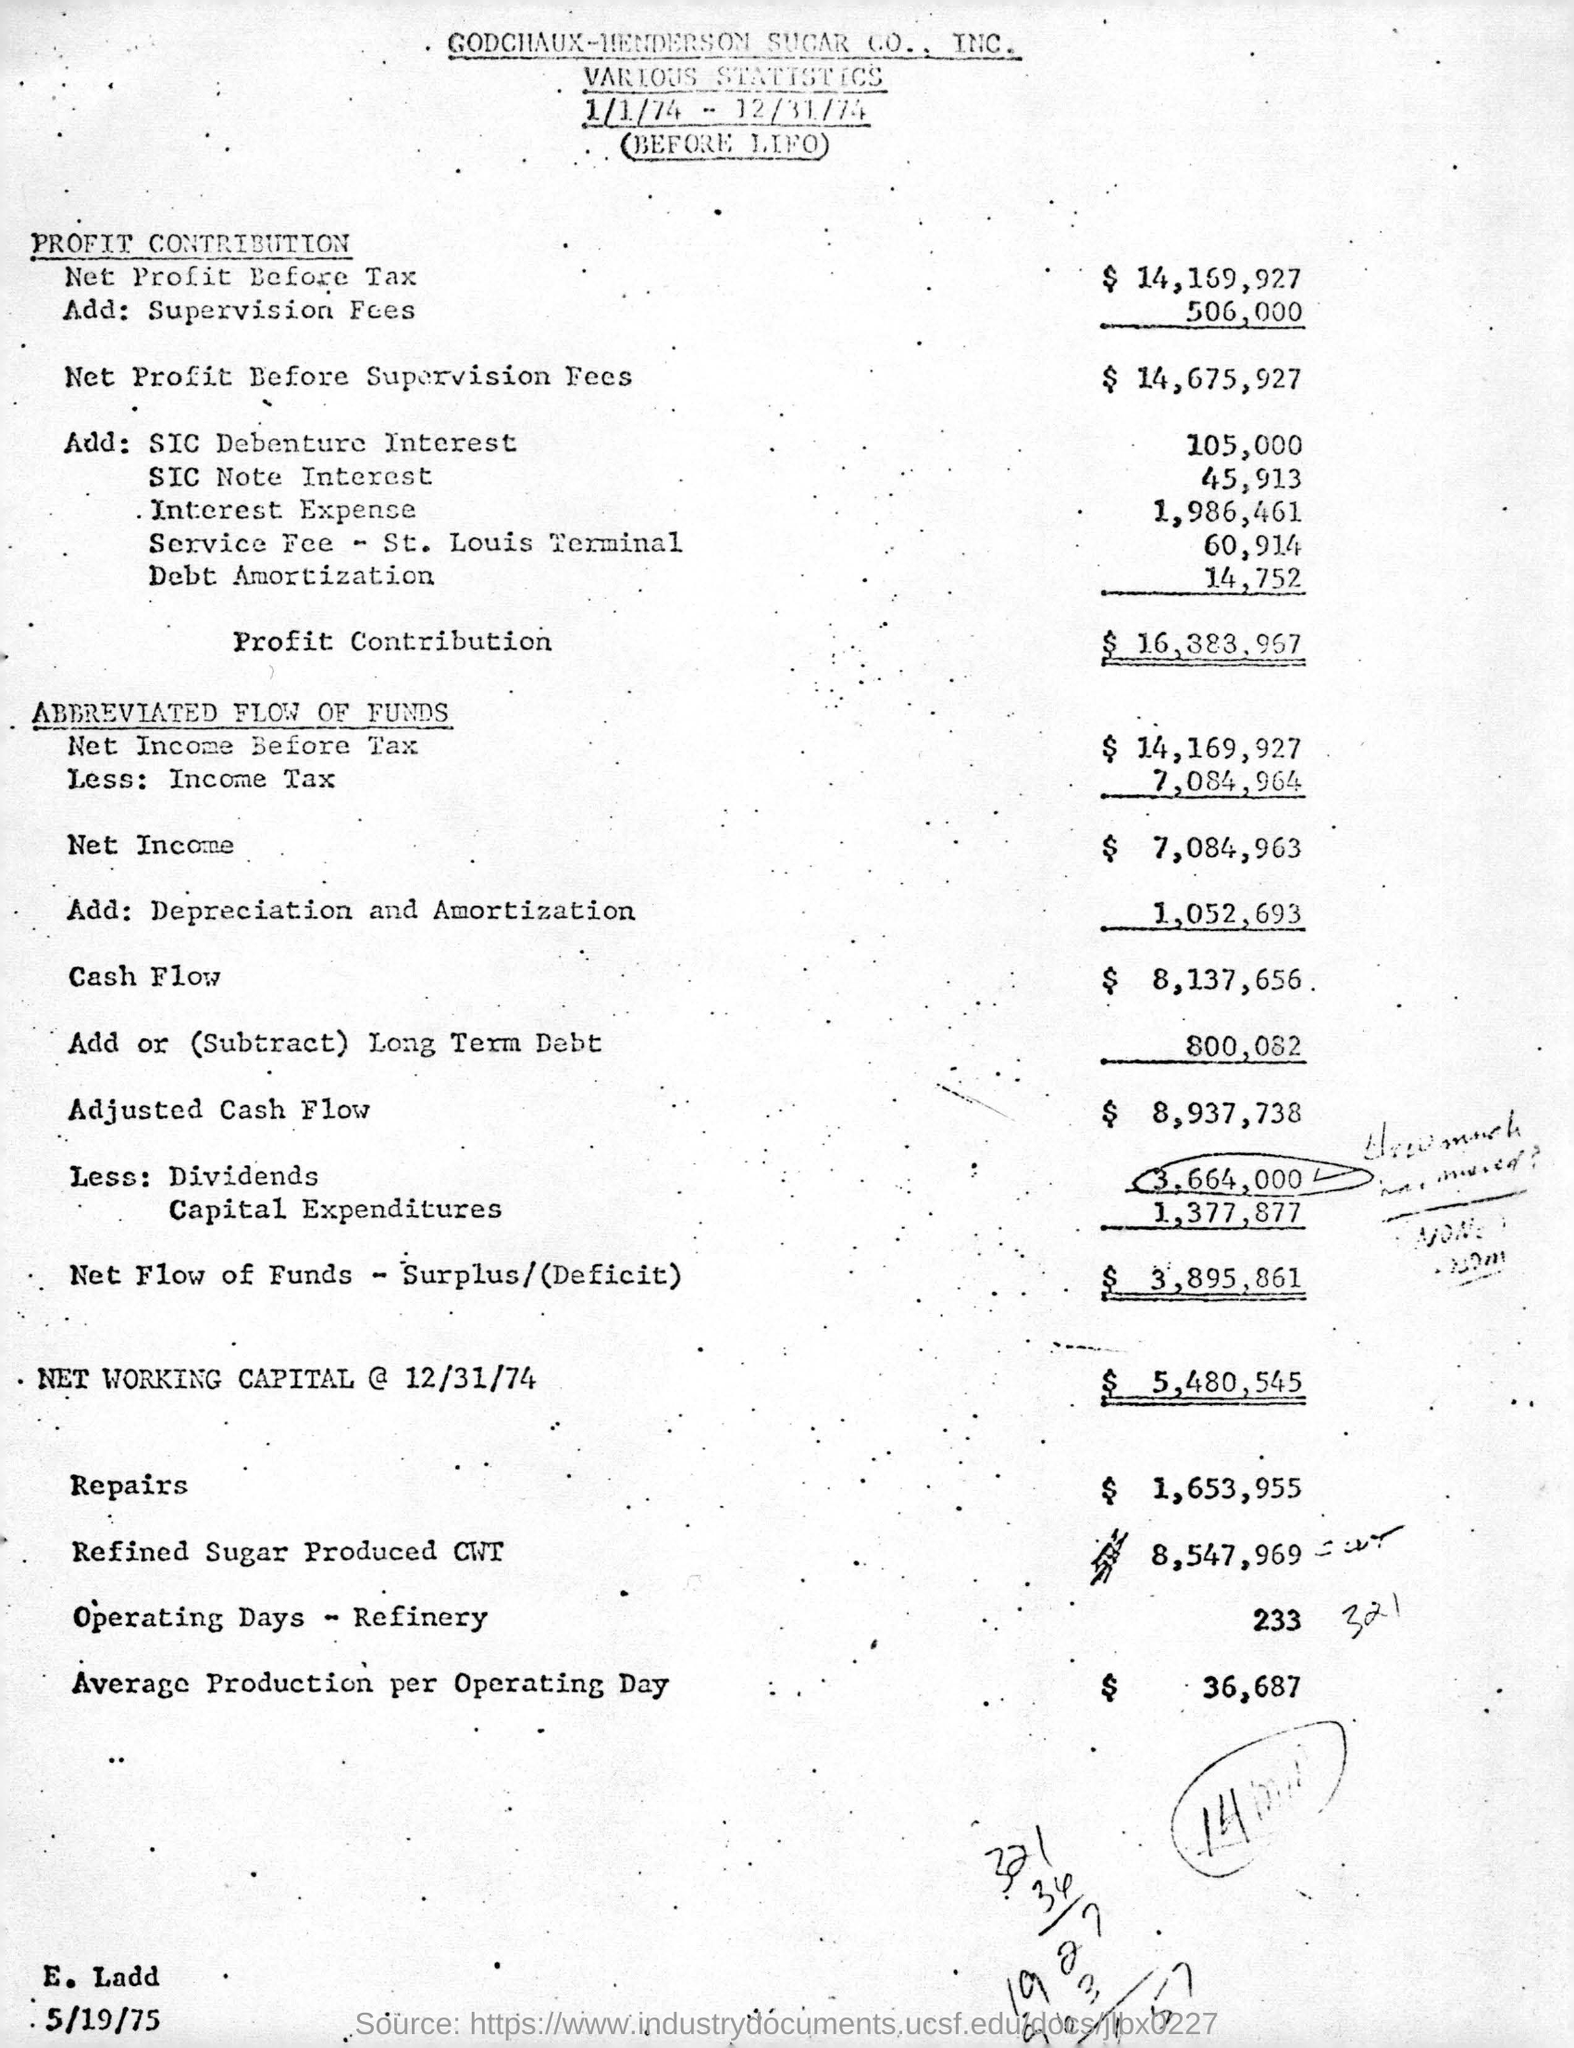Highlight a few significant elements in this photo. The total cost of repairs is 1,653,955. The net income for the given period is $7,084,963. The net profit before tax is 14,169,927... The statistics provided belong to Godchaux-Henderson Sugar Co., Inc. There were 233 days of operating activity at refineries during the relevant time period. 